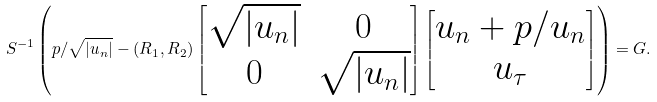Convert formula to latex. <formula><loc_0><loc_0><loc_500><loc_500>S ^ { - 1 } \left ( p / \sqrt { | u _ { n } | } - ( R _ { 1 } , R _ { 2 } ) \begin{bmatrix} \sqrt { | u _ { n } | } & 0 \\ 0 & \sqrt { | u _ { n } | } \end{bmatrix} \begin{bmatrix} u _ { n } + p / u _ { n } \\ u _ { \tau } \end{bmatrix} \right ) = G .</formula> 